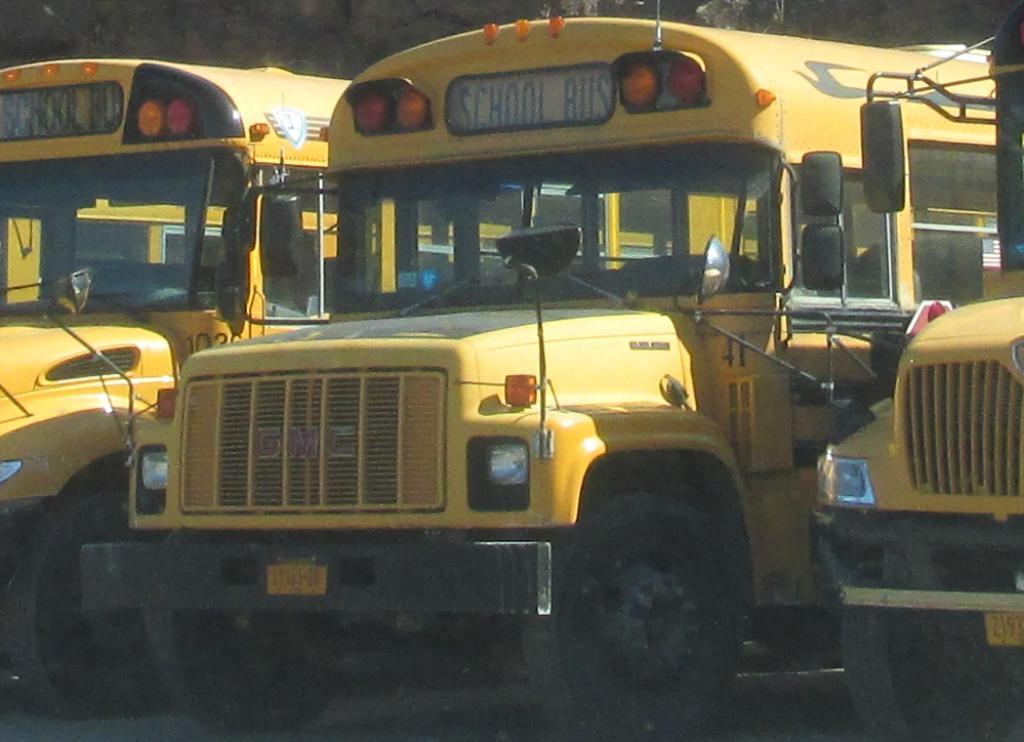In one or two sentences, can you explain what this image depicts? There are yellow color buses with name boards. There are lights on the buses. 